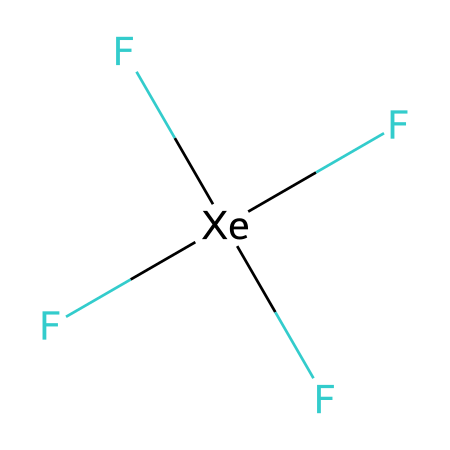how many fluorine atoms are in xenon tetrafluoride? The SMILES representation indicates that there are four fluorine atoms (F) surrounding one xenon atom (Xe). The 'F' shows that it is directly bonded to the xenon atom.
Answer: four what is the central atom in the chemical structure of xenon tetrafluoride? In the given SMILES, the 'Xe' indicates that xenon is the central atom in xenon tetrafluoride, as it is positioned at the middle of the structure with multiple bonds to surrounding F atoms.
Answer: xenon how many total bonds does xenon form in xenon tetrafluoride? Xenon tetrafluoride shows that there are four fluorine atoms bonded to the xenon atom, indicating that there are four bonds formed in total. Each bond corresponds to one fluorine atom connected to xenon.
Answer: four what type of hybridization does xenon exhibit in xenon tetrafluoride? The structure of xenon tetrafluoride shows that the xenon is surrounded by four fluorine atoms, which suggests that it uses sp3 hybridization to accommodate the bonds formed with fluorine.
Answer: sp3 is xenon tetrafluoride a hypervalent compound? Hypervalent compounds are defined as compounds where the central atom has more than eight electrons in its valence shell. In the case of xenon tetrafluoride, xenon has 12 electrons around it (4 bonds to F), confirming that it is hypervalent.
Answer: yes what type of molecular geometry does xenon tetrafluoride have? The presence of four bond pairs (from the fluorine atoms) around the xenon leads to a tetrahedral arrangement of the electron groups in space, which gives the molecule a tetrahedral geometry as a whole.
Answer: tetrahedral which property of xenon tetrafluoride makes it useful in high-intensity lamps? Xenon tetrafluoride is chemically stable and does not readily react with other substances, allowing it to be used effectively in settings like high-intensity lamps without decomposition or unwanted reactions.
Answer: stability 